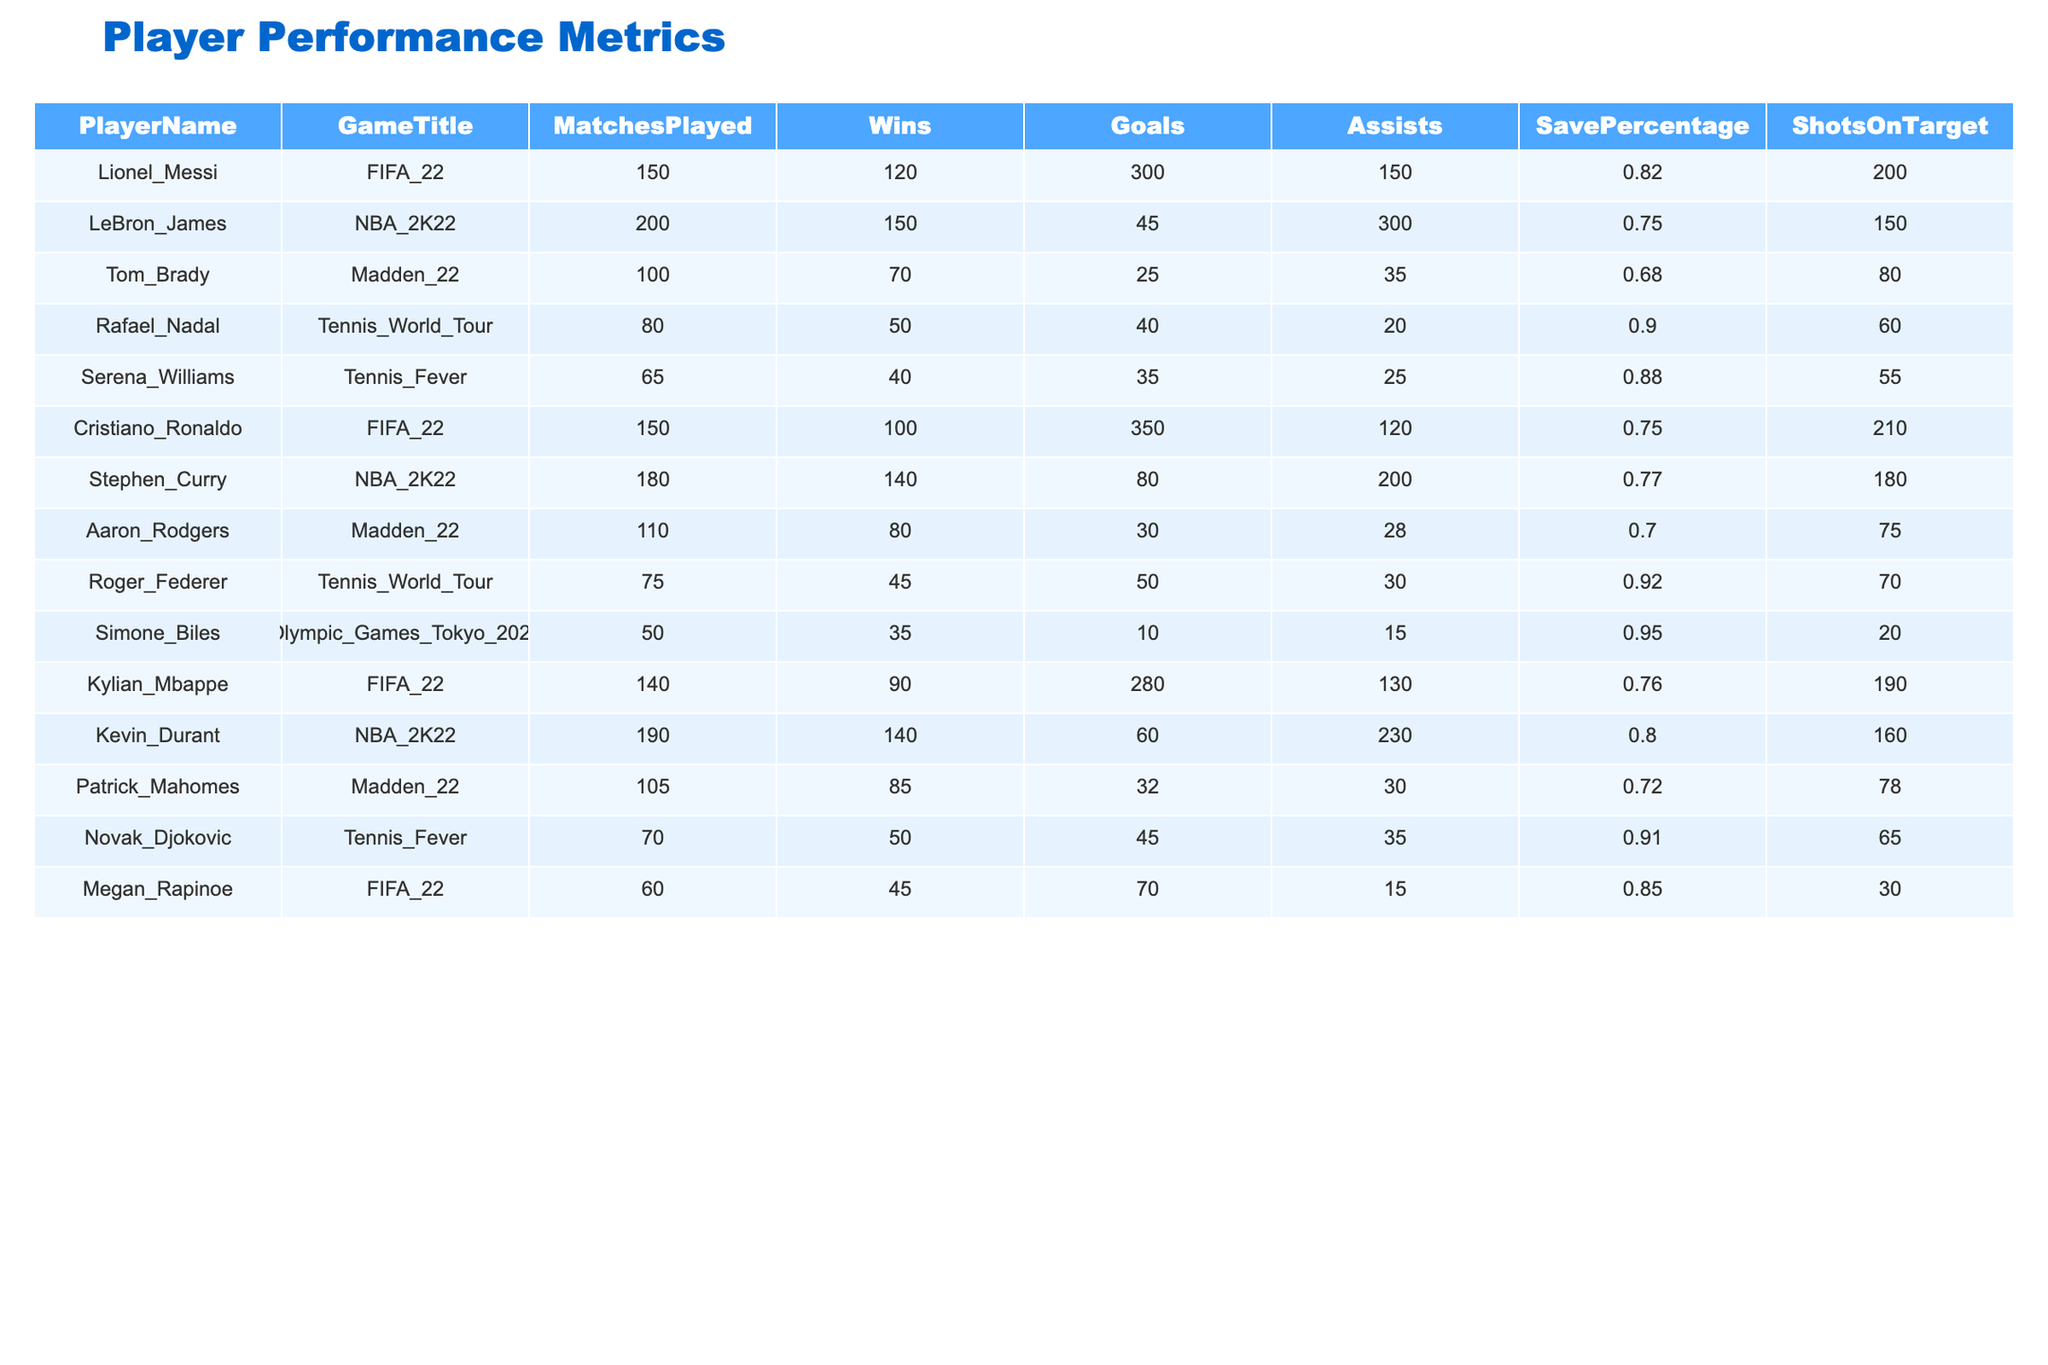What is the total number of wins by Cristiano Ronaldo in FIFA 22? Cristiano Ronaldo has 100 wins in FIFA 22 as shown in the table under the "Wins" column.
Answer: 100 Who has the highest Save Percentage among the players listed? To find the highest Save Percentage, we look through the "SavePercentage" column and see that Simone Biles has the highest value at 0.95.
Answer: 0.95 How many goals did Tom Brady score compared to Rafael Nadal? Tom Brady scored 25 goals while Rafael Nadal scored 40 goals. The difference is 40 - 25 = 15.
Answer: 15 What is the average number of matches played across all players? The total matches played by all players is 150 + 200 + 100 + 80 + 65 + 150 + 180 + 110 + 75 + 50 + 140 + 105 + 70 + 60 = 1,525. There are 13 players, so the average is 1,525 / 13 ≈ 117.31.
Answer: 117.31 Did Kevin Durant win more matches than LeBron James? Kevin Durant won 140 matches while LeBron James won 150 matches. Therefore, Kevin Durant did not win more matches.
Answer: No Which player has the highest total number of goals among all players? By reviewing the "Goals" column, Cristiano Ronaldo has the highest total with 350 goals in FIFA 22.
Answer: 350 Calculate the total number of assists by all players. The total assists can be calculated by summing the "Assists" column: 150 + 300 + 35 + 20 + 25 + 120 + 200 + 28 + 30 + 15 + 130 + 35 + 15 = 1,800.
Answer: 1,800 Who played the fewest matches, and how many did they play? The player with the fewest matches is Simone Biles with 50 matches as seen in the "MatchesPlayed" column.
Answer: 50 Is there a player who has a Save Percentage of 0.90 or higher? Yes, both Rafael Nadal and Roger Federer have Save Percentages of 0.90 and 0.92, respectively.
Answer: Yes Which player had the highest number of matches played in NBA 2K22? Among the players listed for NBA 2K22, LeBron James has the highest matches played with a total of 200.
Answer: 200 